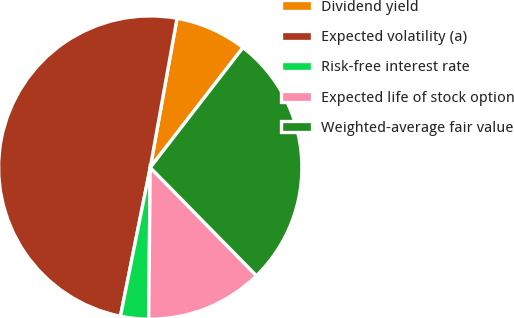<chart> <loc_0><loc_0><loc_500><loc_500><pie_chart><fcel>Dividend yield<fcel>Expected volatility (a)<fcel>Risk-free interest rate<fcel>Expected life of stock option<fcel>Weighted-average fair value<nl><fcel>7.65%<fcel>49.68%<fcel>2.98%<fcel>12.52%<fcel>27.17%<nl></chart> 